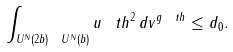<formula> <loc_0><loc_0><loc_500><loc_500>\int _ { U ^ { N } ( 2 b ) \ U ^ { N } ( b ) } u _ { \ } t h ^ { 2 } \, d v ^ { g _ { \ } t h } \leq d _ { 0 } .</formula> 